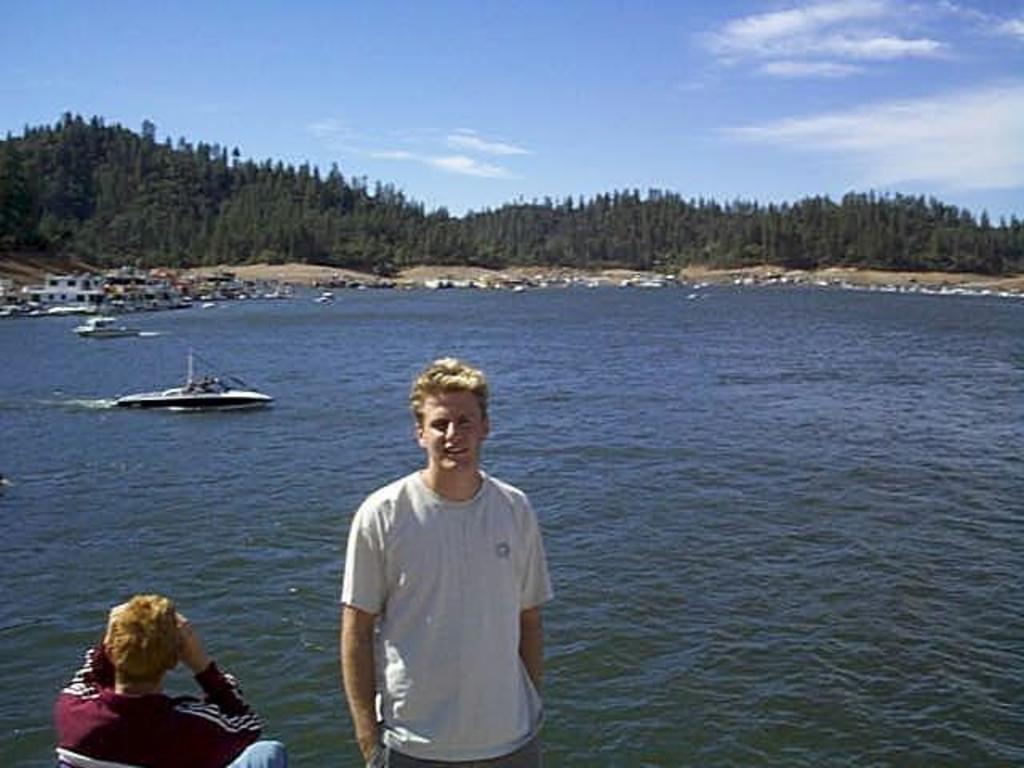Describe this image in one or two sentences. This picture shows trees and boats in the water and we see a man Standing and a man seated and a blue cloudy Sky 